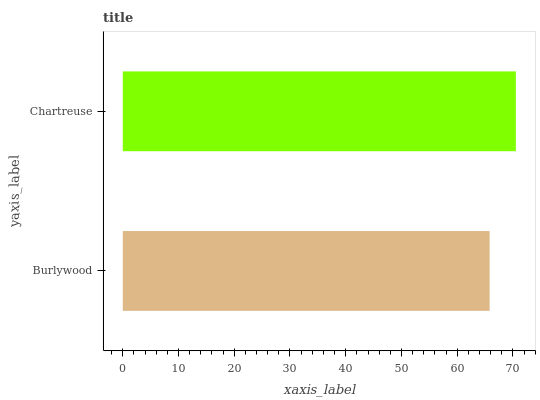Is Burlywood the minimum?
Answer yes or no. Yes. Is Chartreuse the maximum?
Answer yes or no. Yes. Is Chartreuse the minimum?
Answer yes or no. No. Is Chartreuse greater than Burlywood?
Answer yes or no. Yes. Is Burlywood less than Chartreuse?
Answer yes or no. Yes. Is Burlywood greater than Chartreuse?
Answer yes or no. No. Is Chartreuse less than Burlywood?
Answer yes or no. No. Is Chartreuse the high median?
Answer yes or no. Yes. Is Burlywood the low median?
Answer yes or no. Yes. Is Burlywood the high median?
Answer yes or no. No. Is Chartreuse the low median?
Answer yes or no. No. 